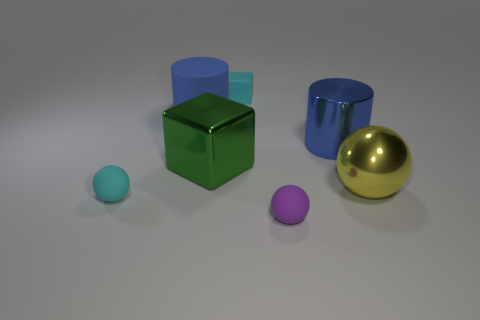Do the large metal cylinder and the large matte cylinder have the same color?
Provide a succinct answer. Yes. What number of rubber objects are left of the green block and in front of the big green metallic block?
Keep it short and to the point. 1. There is a small purple matte object; does it have the same shape as the cyan object that is in front of the large green metal object?
Your answer should be compact. Yes. Are there more blue metallic cylinders that are in front of the large blue metallic cylinder than small cyan metal objects?
Your answer should be compact. No. Is the number of yellow objects to the left of the blue rubber cylinder less than the number of tiny matte balls?
Provide a succinct answer. Yes. How many metallic balls have the same color as the matte block?
Give a very brief answer. 0. There is a small object that is right of the blue matte cylinder and in front of the large matte thing; what material is it?
Your answer should be compact. Rubber. Is the color of the cylinder that is to the right of the green shiny object the same as the metallic thing that is to the left of the small purple rubber sphere?
Offer a terse response. No. How many purple objects are either rubber objects or tiny metallic cubes?
Provide a succinct answer. 1. Is the number of large shiny cubes that are behind the shiny cylinder less than the number of big green metal objects that are to the left of the large green block?
Give a very brief answer. No. 